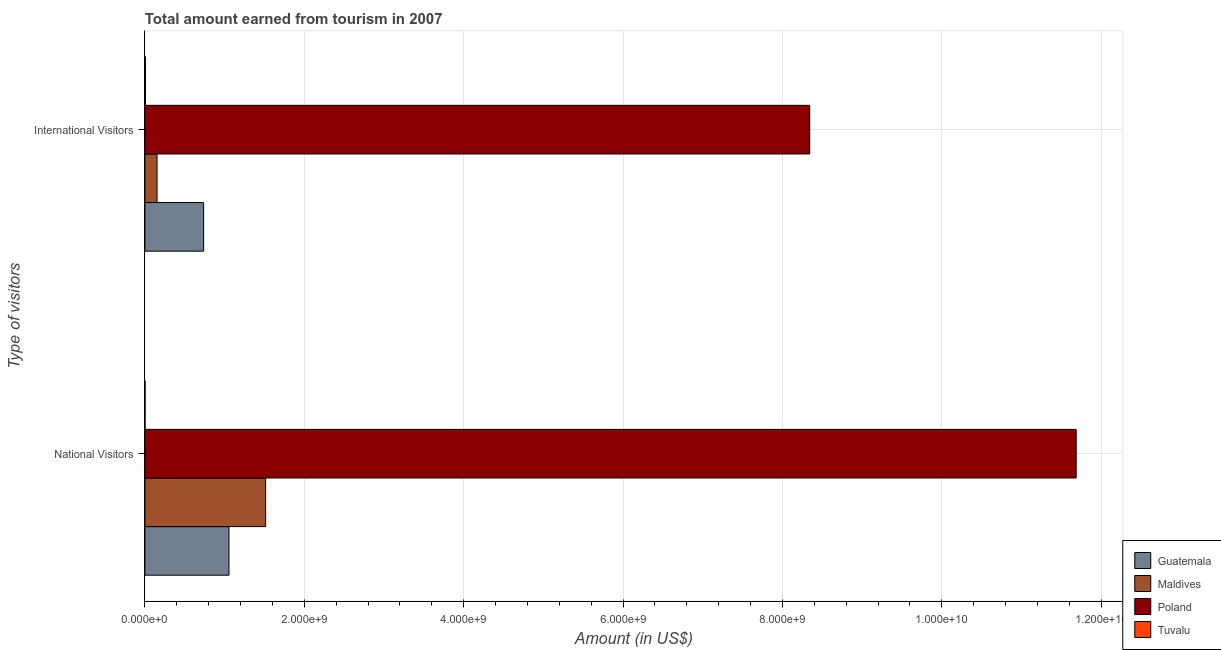How many different coloured bars are there?
Your response must be concise. 4. What is the label of the 2nd group of bars from the top?
Keep it short and to the point. National Visitors. What is the amount earned from national visitors in Poland?
Make the answer very short. 1.17e+1. Across all countries, what is the maximum amount earned from national visitors?
Give a very brief answer. 1.17e+1. Across all countries, what is the minimum amount earned from national visitors?
Offer a very short reply. 1.51e+06. In which country was the amount earned from international visitors minimum?
Give a very brief answer. Tuvalu. What is the total amount earned from national visitors in the graph?
Your answer should be compact. 1.43e+1. What is the difference between the amount earned from international visitors in Poland and that in Guatemala?
Give a very brief answer. 7.60e+09. What is the difference between the amount earned from national visitors in Guatemala and the amount earned from international visitors in Poland?
Ensure brevity in your answer.  -7.29e+09. What is the average amount earned from national visitors per country?
Your answer should be compact. 3.56e+09. What is the difference between the amount earned from national visitors and amount earned from international visitors in Poland?
Ensure brevity in your answer.  3.34e+09. In how many countries, is the amount earned from national visitors greater than 2800000000 US$?
Give a very brief answer. 1. What is the ratio of the amount earned from international visitors in Poland to that in Maldives?
Your response must be concise. 54.88. What does the 1st bar from the top in National Visitors represents?
Your response must be concise. Tuvalu. What does the 3rd bar from the bottom in National Visitors represents?
Provide a succinct answer. Poland. Are the values on the major ticks of X-axis written in scientific E-notation?
Ensure brevity in your answer.  Yes. How many legend labels are there?
Give a very brief answer. 4. How are the legend labels stacked?
Offer a very short reply. Vertical. What is the title of the graph?
Keep it short and to the point. Total amount earned from tourism in 2007. Does "Austria" appear as one of the legend labels in the graph?
Provide a short and direct response. No. What is the label or title of the Y-axis?
Make the answer very short. Type of visitors. What is the Amount (in US$) of Guatemala in National Visitors?
Provide a succinct answer. 1.06e+09. What is the Amount (in US$) of Maldives in National Visitors?
Provide a short and direct response. 1.52e+09. What is the Amount (in US$) in Poland in National Visitors?
Give a very brief answer. 1.17e+1. What is the Amount (in US$) in Tuvalu in National Visitors?
Ensure brevity in your answer.  1.51e+06. What is the Amount (in US$) in Guatemala in International Visitors?
Offer a terse response. 7.37e+08. What is the Amount (in US$) in Maldives in International Visitors?
Offer a terse response. 1.52e+08. What is the Amount (in US$) of Poland in International Visitors?
Provide a succinct answer. 8.34e+09. What is the Amount (in US$) in Tuvalu in International Visitors?
Make the answer very short. 6.89e+06. Across all Type of visitors, what is the maximum Amount (in US$) in Guatemala?
Provide a succinct answer. 1.06e+09. Across all Type of visitors, what is the maximum Amount (in US$) in Maldives?
Give a very brief answer. 1.52e+09. Across all Type of visitors, what is the maximum Amount (in US$) in Poland?
Ensure brevity in your answer.  1.17e+1. Across all Type of visitors, what is the maximum Amount (in US$) in Tuvalu?
Offer a very short reply. 6.89e+06. Across all Type of visitors, what is the minimum Amount (in US$) in Guatemala?
Your response must be concise. 7.37e+08. Across all Type of visitors, what is the minimum Amount (in US$) of Maldives?
Offer a terse response. 1.52e+08. Across all Type of visitors, what is the minimum Amount (in US$) in Poland?
Offer a very short reply. 8.34e+09. Across all Type of visitors, what is the minimum Amount (in US$) of Tuvalu?
Your answer should be compact. 1.51e+06. What is the total Amount (in US$) of Guatemala in the graph?
Provide a short and direct response. 1.79e+09. What is the total Amount (in US$) in Maldives in the graph?
Your answer should be compact. 1.67e+09. What is the total Amount (in US$) of Poland in the graph?
Offer a very short reply. 2.00e+1. What is the total Amount (in US$) of Tuvalu in the graph?
Offer a terse response. 8.40e+06. What is the difference between the Amount (in US$) in Guatemala in National Visitors and that in International Visitors?
Your answer should be compact. 3.18e+08. What is the difference between the Amount (in US$) of Maldives in National Visitors and that in International Visitors?
Keep it short and to the point. 1.36e+09. What is the difference between the Amount (in US$) in Poland in National Visitors and that in International Visitors?
Your answer should be very brief. 3.34e+09. What is the difference between the Amount (in US$) in Tuvalu in National Visitors and that in International Visitors?
Your answer should be compact. -5.38e+06. What is the difference between the Amount (in US$) in Guatemala in National Visitors and the Amount (in US$) in Maldives in International Visitors?
Ensure brevity in your answer.  9.03e+08. What is the difference between the Amount (in US$) of Guatemala in National Visitors and the Amount (in US$) of Poland in International Visitors?
Keep it short and to the point. -7.29e+09. What is the difference between the Amount (in US$) in Guatemala in National Visitors and the Amount (in US$) in Tuvalu in International Visitors?
Provide a short and direct response. 1.05e+09. What is the difference between the Amount (in US$) of Maldives in National Visitors and the Amount (in US$) of Poland in International Visitors?
Your response must be concise. -6.83e+09. What is the difference between the Amount (in US$) of Maldives in National Visitors and the Amount (in US$) of Tuvalu in International Visitors?
Give a very brief answer. 1.51e+09. What is the difference between the Amount (in US$) in Poland in National Visitors and the Amount (in US$) in Tuvalu in International Visitors?
Offer a very short reply. 1.17e+1. What is the average Amount (in US$) in Guatemala per Type of visitors?
Your answer should be compact. 8.96e+08. What is the average Amount (in US$) in Maldives per Type of visitors?
Make the answer very short. 8.34e+08. What is the average Amount (in US$) of Poland per Type of visitors?
Make the answer very short. 1.00e+1. What is the average Amount (in US$) in Tuvalu per Type of visitors?
Ensure brevity in your answer.  4.20e+06. What is the difference between the Amount (in US$) of Guatemala and Amount (in US$) of Maldives in National Visitors?
Offer a terse response. -4.60e+08. What is the difference between the Amount (in US$) in Guatemala and Amount (in US$) in Poland in National Visitors?
Your response must be concise. -1.06e+1. What is the difference between the Amount (in US$) of Guatemala and Amount (in US$) of Tuvalu in National Visitors?
Offer a terse response. 1.05e+09. What is the difference between the Amount (in US$) of Maldives and Amount (in US$) of Poland in National Visitors?
Your response must be concise. -1.02e+1. What is the difference between the Amount (in US$) in Maldives and Amount (in US$) in Tuvalu in National Visitors?
Make the answer very short. 1.51e+09. What is the difference between the Amount (in US$) in Poland and Amount (in US$) in Tuvalu in National Visitors?
Your answer should be very brief. 1.17e+1. What is the difference between the Amount (in US$) of Guatemala and Amount (in US$) of Maldives in International Visitors?
Make the answer very short. 5.85e+08. What is the difference between the Amount (in US$) in Guatemala and Amount (in US$) in Poland in International Visitors?
Offer a terse response. -7.60e+09. What is the difference between the Amount (in US$) of Guatemala and Amount (in US$) of Tuvalu in International Visitors?
Keep it short and to the point. 7.30e+08. What is the difference between the Amount (in US$) in Maldives and Amount (in US$) in Poland in International Visitors?
Provide a short and direct response. -8.19e+09. What is the difference between the Amount (in US$) in Maldives and Amount (in US$) in Tuvalu in International Visitors?
Provide a short and direct response. 1.45e+08. What is the difference between the Amount (in US$) of Poland and Amount (in US$) of Tuvalu in International Visitors?
Your answer should be very brief. 8.34e+09. What is the ratio of the Amount (in US$) in Guatemala in National Visitors to that in International Visitors?
Give a very brief answer. 1.43. What is the ratio of the Amount (in US$) of Maldives in National Visitors to that in International Visitors?
Your answer should be very brief. 9.97. What is the ratio of the Amount (in US$) of Poland in National Visitors to that in International Visitors?
Your answer should be compact. 1.4. What is the ratio of the Amount (in US$) in Tuvalu in National Visitors to that in International Visitors?
Your response must be concise. 0.22. What is the difference between the highest and the second highest Amount (in US$) of Guatemala?
Your answer should be compact. 3.18e+08. What is the difference between the highest and the second highest Amount (in US$) in Maldives?
Give a very brief answer. 1.36e+09. What is the difference between the highest and the second highest Amount (in US$) in Poland?
Keep it short and to the point. 3.34e+09. What is the difference between the highest and the second highest Amount (in US$) in Tuvalu?
Keep it short and to the point. 5.38e+06. What is the difference between the highest and the lowest Amount (in US$) in Guatemala?
Your response must be concise. 3.18e+08. What is the difference between the highest and the lowest Amount (in US$) in Maldives?
Your answer should be very brief. 1.36e+09. What is the difference between the highest and the lowest Amount (in US$) in Poland?
Your response must be concise. 3.34e+09. What is the difference between the highest and the lowest Amount (in US$) in Tuvalu?
Offer a very short reply. 5.38e+06. 